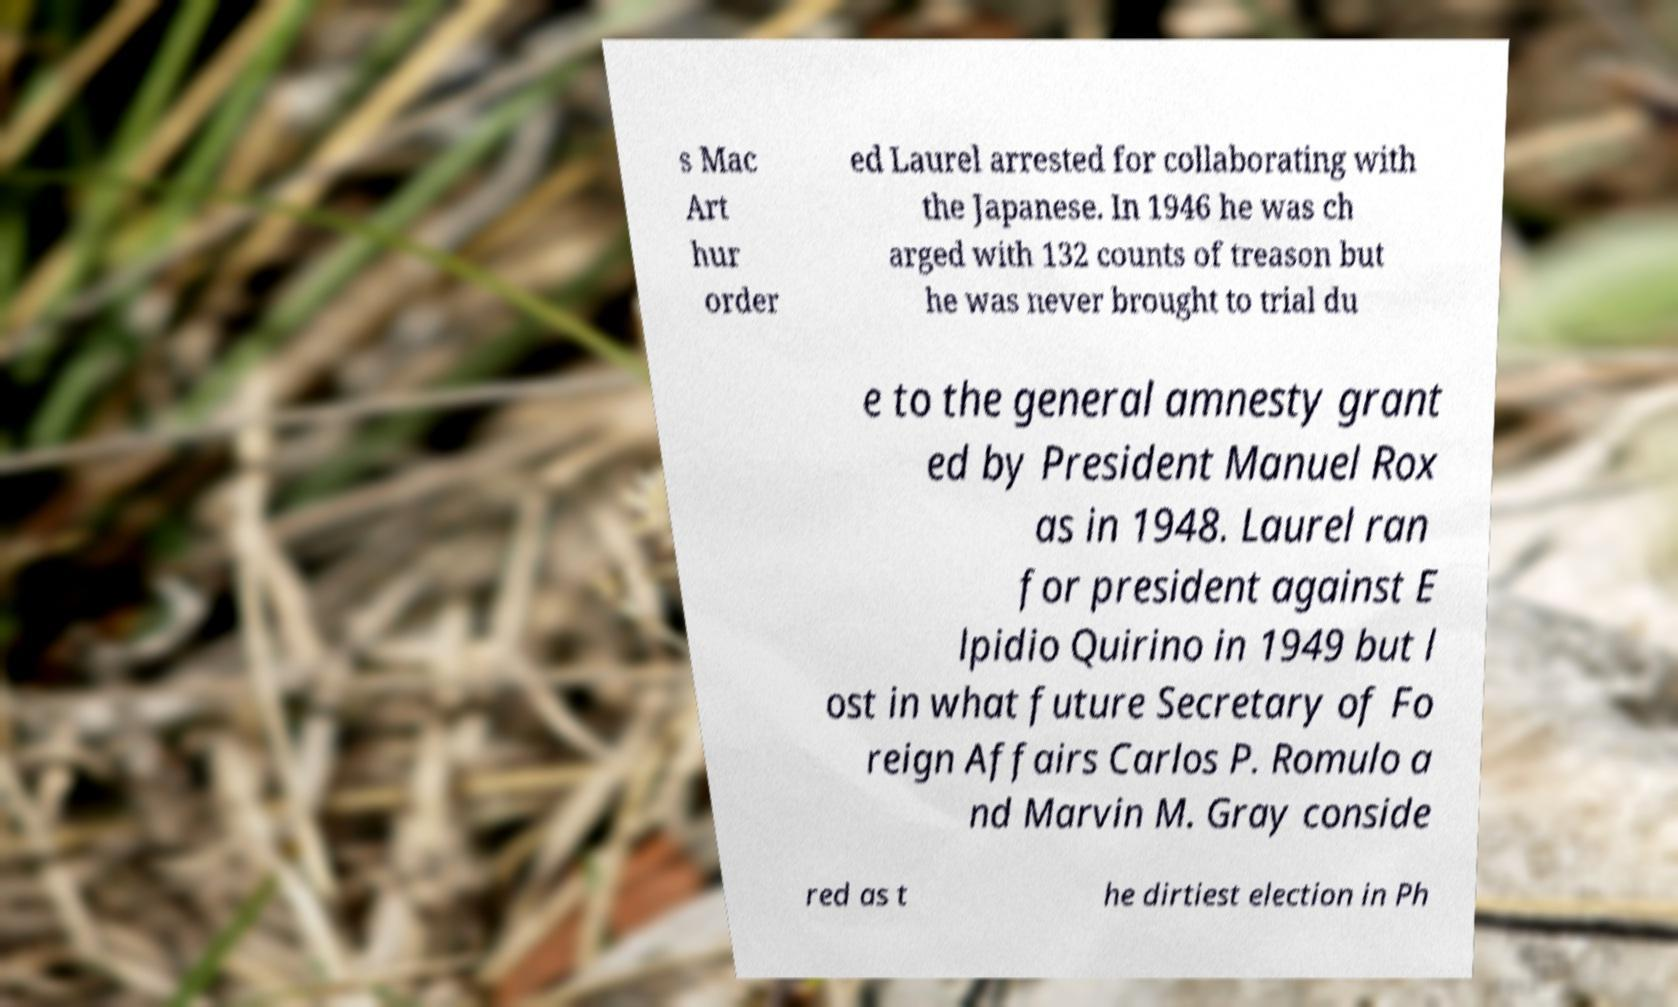Please identify and transcribe the text found in this image. s Mac Art hur order ed Laurel arrested for collaborating with the Japanese. In 1946 he was ch arged with 132 counts of treason but he was never brought to trial du e to the general amnesty grant ed by President Manuel Rox as in 1948. Laurel ran for president against E lpidio Quirino in 1949 but l ost in what future Secretary of Fo reign Affairs Carlos P. Romulo a nd Marvin M. Gray conside red as t he dirtiest election in Ph 